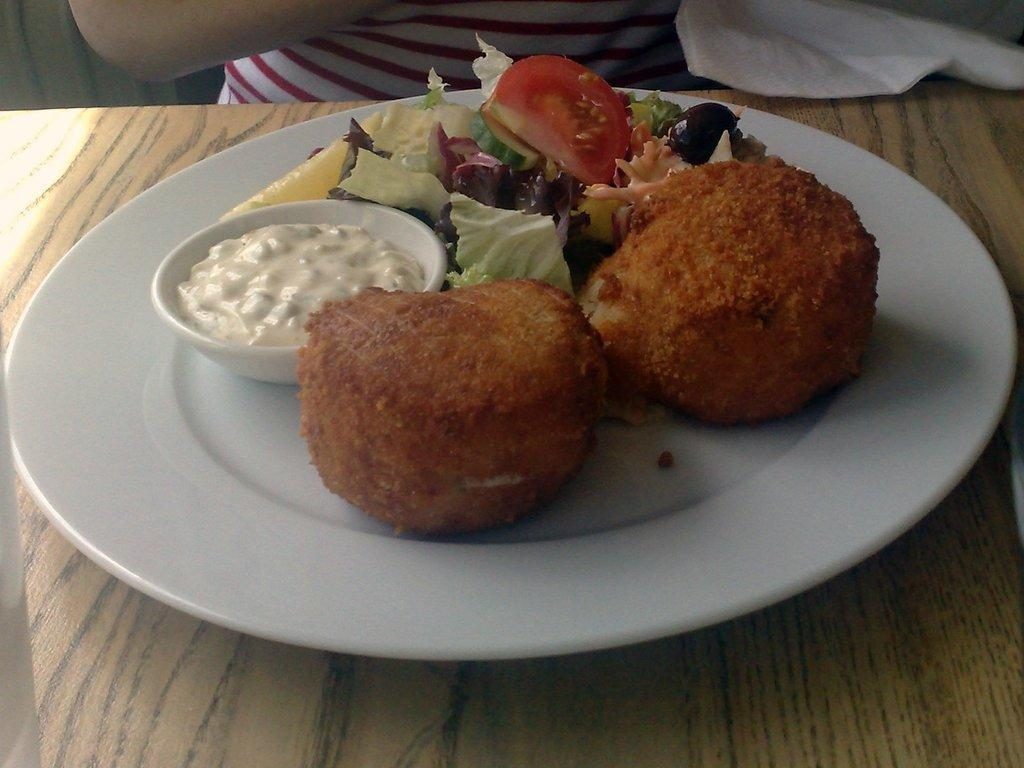What is on the wooden surface in the image? There is a plate on the wooden surface. What is on the plate? There is a bowl on the plate, and there are food items on the plate. Can you describe the person in the background of the image? The facts provided do not give any details about the person in the background. What is the tissue paper used for in the image? The facts provided do not give any details about the purpose of the tissue paper in the image. What shape is the family depicted in the image? There is no family depicted in the image, and therefore no shape can be assigned to them. What design is featured on the person's clothing in the image? The facts provided do not give any details about the person's clothing or any design on it. 